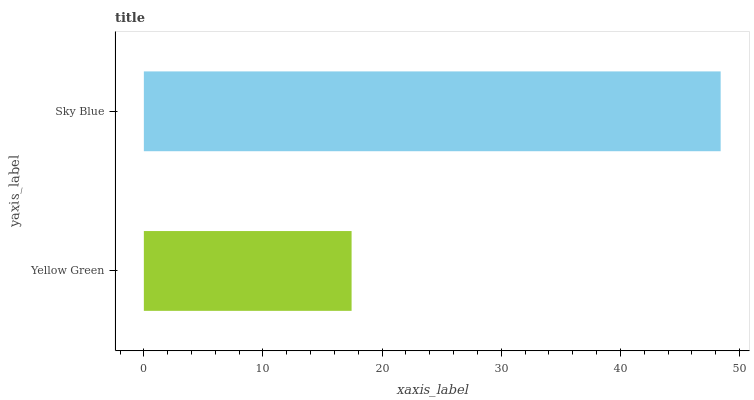Is Yellow Green the minimum?
Answer yes or no. Yes. Is Sky Blue the maximum?
Answer yes or no. Yes. Is Sky Blue the minimum?
Answer yes or no. No. Is Sky Blue greater than Yellow Green?
Answer yes or no. Yes. Is Yellow Green less than Sky Blue?
Answer yes or no. Yes. Is Yellow Green greater than Sky Blue?
Answer yes or no. No. Is Sky Blue less than Yellow Green?
Answer yes or no. No. Is Sky Blue the high median?
Answer yes or no. Yes. Is Yellow Green the low median?
Answer yes or no. Yes. Is Yellow Green the high median?
Answer yes or no. No. Is Sky Blue the low median?
Answer yes or no. No. 